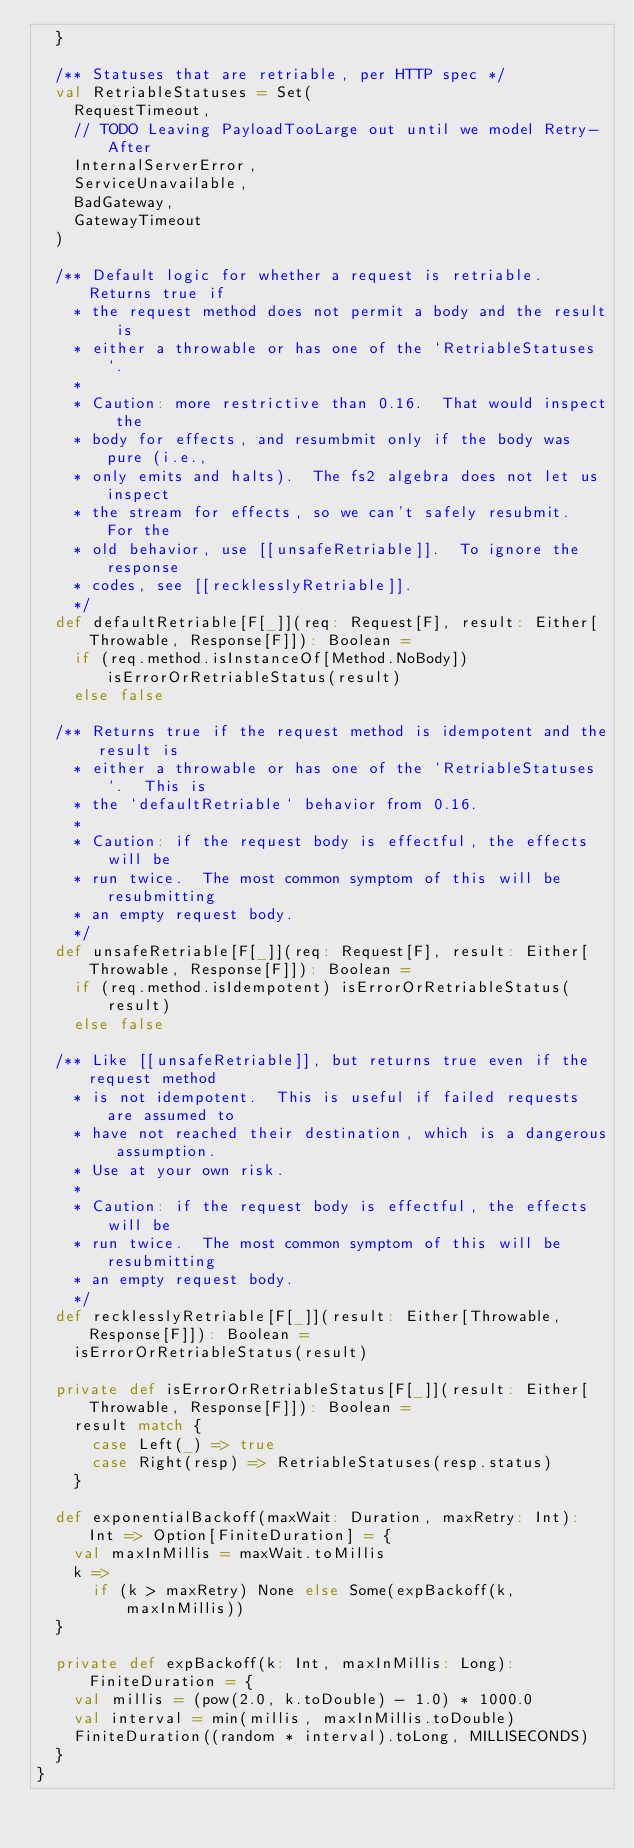Convert code to text. <code><loc_0><loc_0><loc_500><loc_500><_Scala_>  }

  /** Statuses that are retriable, per HTTP spec */
  val RetriableStatuses = Set(
    RequestTimeout,
    // TODO Leaving PayloadTooLarge out until we model Retry-After
    InternalServerError,
    ServiceUnavailable,
    BadGateway,
    GatewayTimeout
  )

  /** Default logic for whether a request is retriable.  Returns true if
    * the request method does not permit a body and the result is
    * either a throwable or has one of the `RetriableStatuses`.
    *
    * Caution: more restrictive than 0.16.  That would inspect the
    * body for effects, and resumbmit only if the body was pure (i.e.,
    * only emits and halts).  The fs2 algebra does not let us inspect
    * the stream for effects, so we can't safely resubmit.  For the
    * old behavior, use [[unsafeRetriable]].  To ignore the response
    * codes, see [[recklesslyRetriable]].
    */
  def defaultRetriable[F[_]](req: Request[F], result: Either[Throwable, Response[F]]): Boolean =
    if (req.method.isInstanceOf[Method.NoBody]) isErrorOrRetriableStatus(result)
    else false

  /** Returns true if the request method is idempotent and the result is
    * either a throwable or has one of the `RetriableStatuses`.  This is
    * the `defaultRetriable` behavior from 0.16.
    *
    * Caution: if the request body is effectful, the effects will be
    * run twice.  The most common symptom of this will be resubmitting
    * an empty request body.
    */
  def unsafeRetriable[F[_]](req: Request[F], result: Either[Throwable, Response[F]]): Boolean =
    if (req.method.isIdempotent) isErrorOrRetriableStatus(result)
    else false

  /** Like [[unsafeRetriable]], but returns true even if the request method
    * is not idempotent.  This is useful if failed requests are assumed to
    * have not reached their destination, which is a dangerous assumption.
    * Use at your own risk.
    *
    * Caution: if the request body is effectful, the effects will be
    * run twice.  The most common symptom of this will be resubmitting
    * an empty request body.
    */
  def recklesslyRetriable[F[_]](result: Either[Throwable, Response[F]]): Boolean =
    isErrorOrRetriableStatus(result)

  private def isErrorOrRetriableStatus[F[_]](result: Either[Throwable, Response[F]]): Boolean =
    result match {
      case Left(_) => true
      case Right(resp) => RetriableStatuses(resp.status)
    }

  def exponentialBackoff(maxWait: Duration, maxRetry: Int): Int => Option[FiniteDuration] = {
    val maxInMillis = maxWait.toMillis
    k =>
      if (k > maxRetry) None else Some(expBackoff(k, maxInMillis))
  }

  private def expBackoff(k: Int, maxInMillis: Long): FiniteDuration = {
    val millis = (pow(2.0, k.toDouble) - 1.0) * 1000.0
    val interval = min(millis, maxInMillis.toDouble)
    FiniteDuration((random * interval).toLong, MILLISECONDS)
  }
}
</code> 